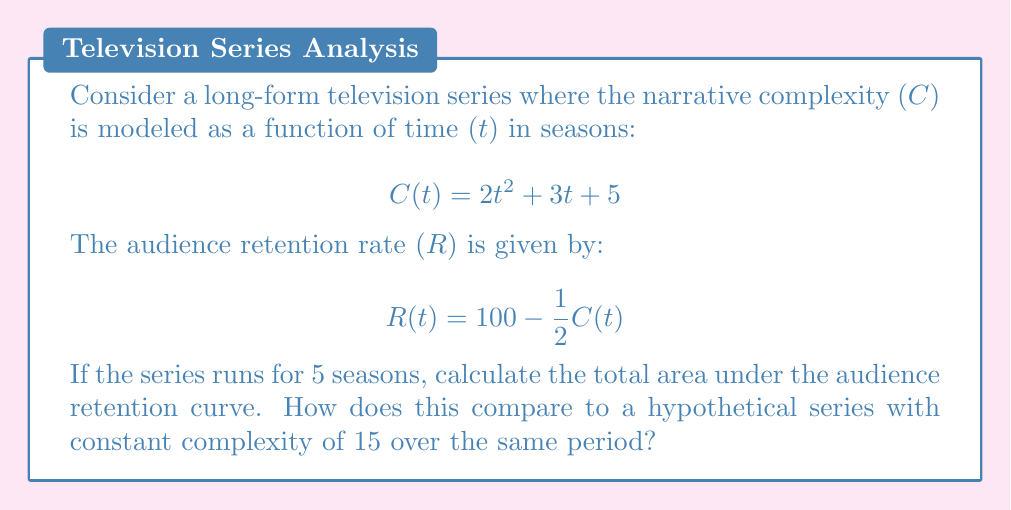Could you help me with this problem? To solve this problem, we need to follow these steps:

1. Calculate the audience retention rate for each season.
2. Find the area under the retention curve using integration.
3. Compare with a constant complexity series.

Step 1: Calculate retention rate for each season
For $t = 1$ to $5$, we calculate $C(t)$ and then $R(t)$:

Season 1: $C(1) = 2(1)^2 + 3(1) + 5 = 10$, $R(1) = 100 - \frac{1}{2}(10) = 95$
Season 2: $C(2) = 2(2)^2 + 3(2) + 5 = 19$, $R(2) = 100 - \frac{1}{2}(19) = 90.5$
Season 3: $C(3) = 2(3)^2 + 3(3) + 5 = 32$, $R(3) = 100 - \frac{1}{2}(32) = 84$
Season 4: $C(4) = 2(4)^2 + 3(4) + 5 = 49$, $R(4) = 100 - \frac{1}{2}(49) = 75.5$
Season 5: $C(5) = 2(5)^2 + 3(5) + 5 = 70$, $R(5) = 100 - \frac{1}{2}(70) = 65$

Step 2: Find the area under the retention curve
We need to integrate $R(t)$ from $t=0$ to $t=5$:

$$\int_0^5 R(t) dt = \int_0^5 (100 - \frac{1}{2}C(t)) dt$$
$$= \int_0^5 (100 - \frac{1}{2}(2t^2 + 3t + 5)) dt$$
$$= \int_0^5 (100 - t^2 - \frac{3}{2}t - \frac{5}{2}) dt$$
$$= [100t - \frac{1}{3}t^3 - \frac{3}{4}t^2 - \frac{5}{2}t]_0^5$$
$$= (500 - \frac{125}{3} - \frac{75}{4} - \frac{25}{2}) - 0$$
$$= 500 - 41.67 - 18.75 - 12.5 = 427.08$$

Step 3: Compare with constant complexity series
For a series with constant complexity of 15, the retention rate would be:
$$R = 100 - \frac{1}{2}(15) = 92.5$$

The area under this constant retention curve over 5 seasons would be:
$$92.5 * 5 = 462.5$$

The difference between the two areas is:
$$462.5 - 427.08 = 35.42$$

This means the series with increasing complexity retains about 35.42 fewer audience-seasons compared to a hypothetical series with constant moderate complexity.
Answer: The total area under the audience retention curve for the given series is approximately 427.08 audience-seasons. This is 35.42 audience-seasons less than a hypothetical series with constant complexity of 15, which would have 462.5 audience-seasons. 